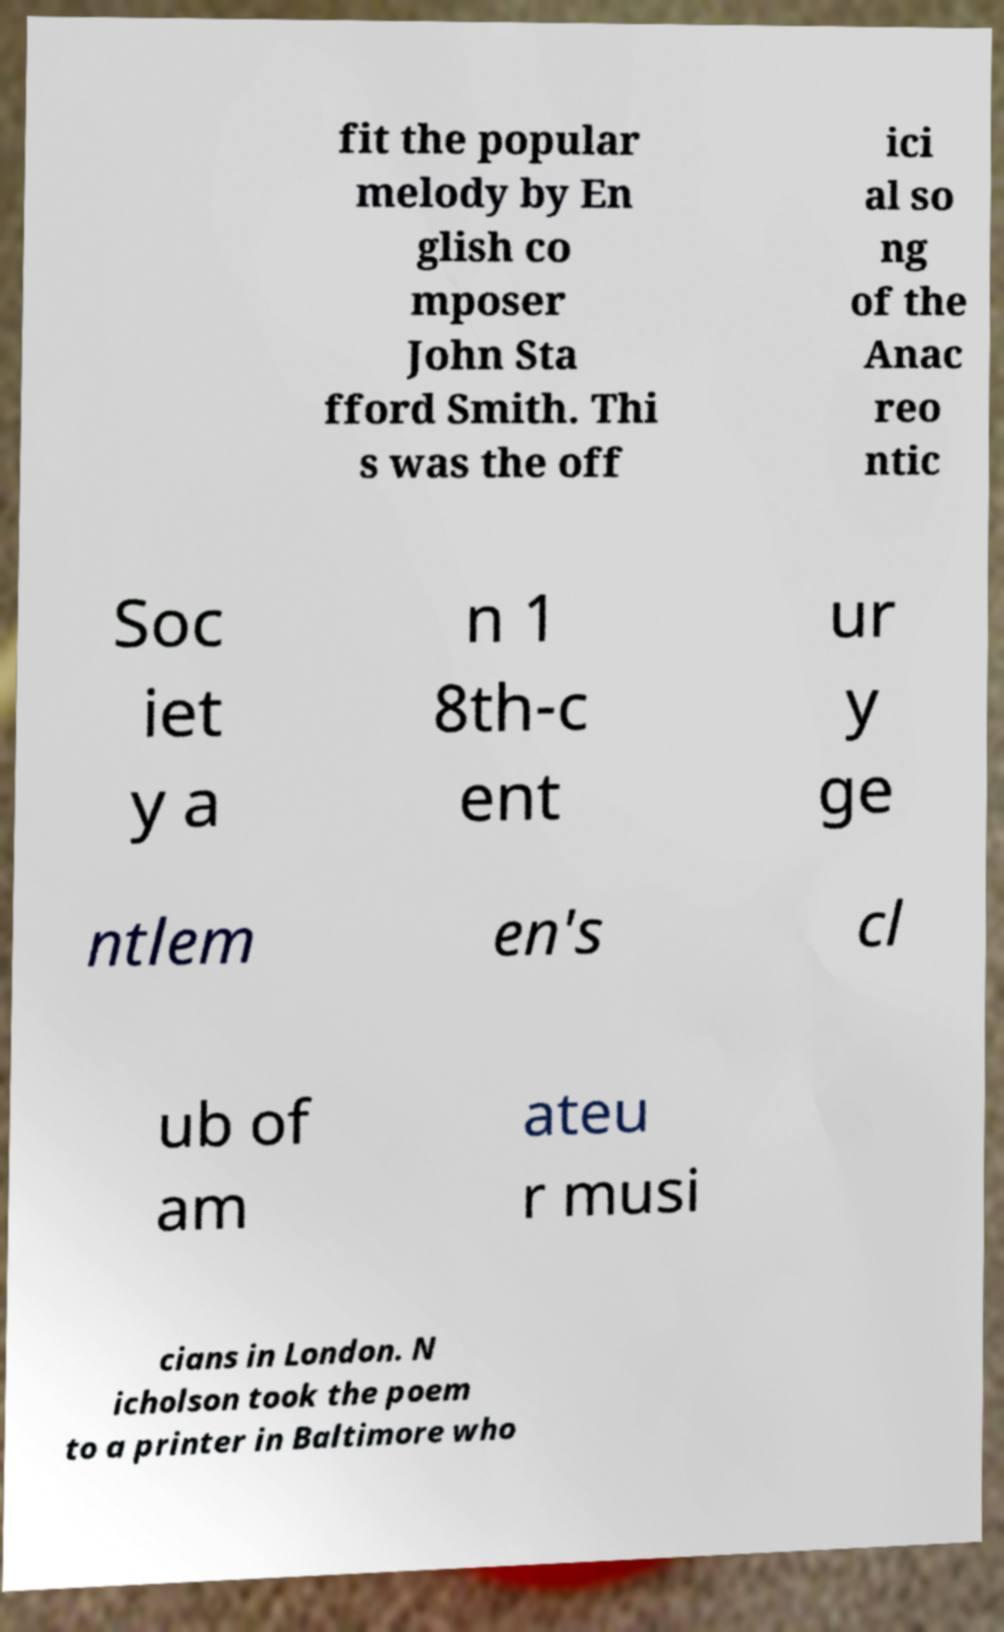Please identify and transcribe the text found in this image. fit the popular melody by En glish co mposer John Sta fford Smith. Thi s was the off ici al so ng of the Anac reo ntic Soc iet y a n 1 8th-c ent ur y ge ntlem en's cl ub of am ateu r musi cians in London. N icholson took the poem to a printer in Baltimore who 